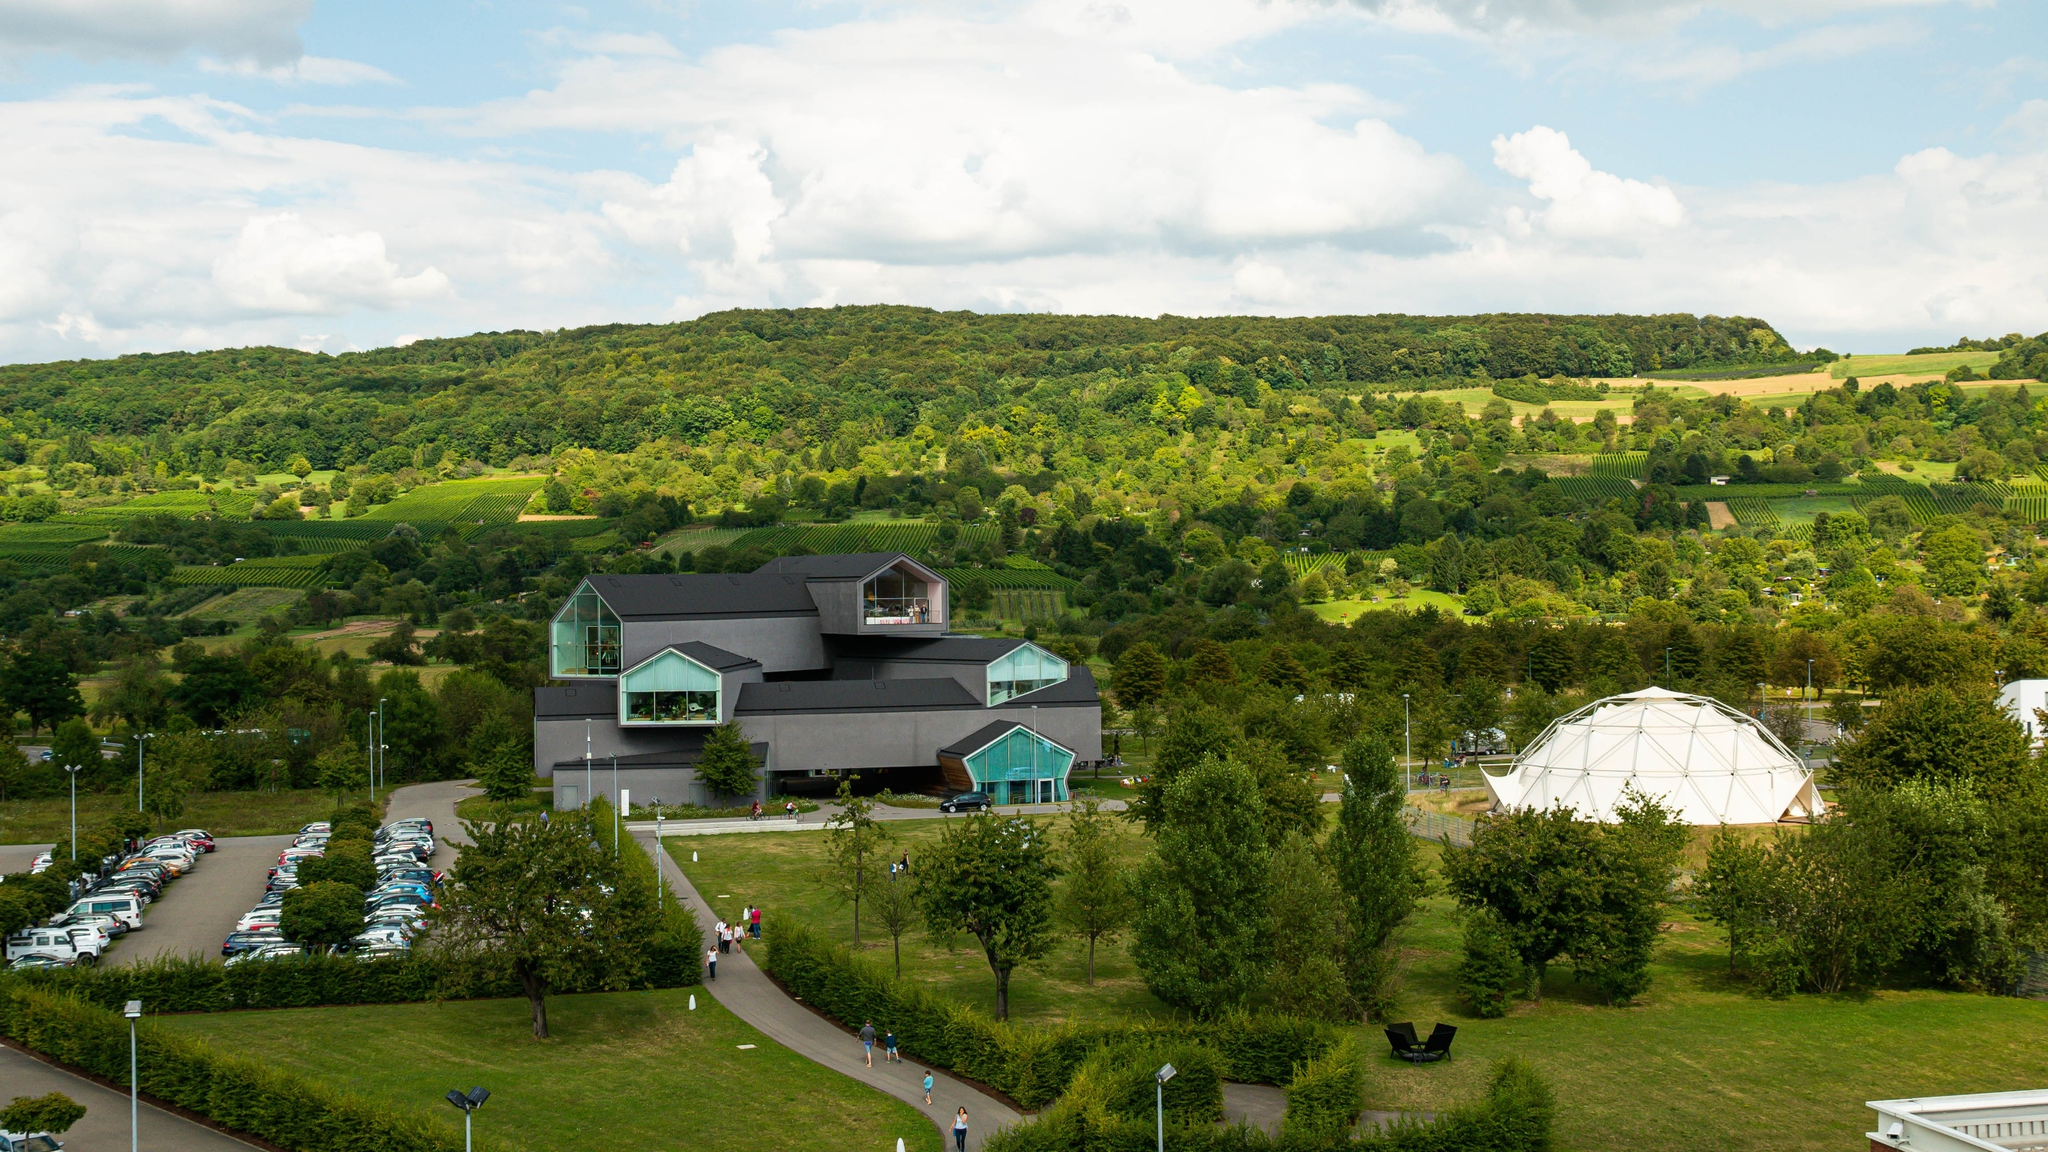Can you imagine what it would be like to visit this place on a sunny day? Visiting the Vitra Design Museum on a sunny day would be a delightful experience. The journey to the museum would likely begin with a scenic drive through the rolling hills and greenery of Weil am Rhein. Upon arrival, the sleek, black exterior of the museum would be accentuated by the bright sunlight, making the triangular windows sparkle. The numerous visitors' cars would indicate that it’s a popular destination. Walking through the museum’s surrounding gardens, one could appreciate the lush, green landscape set against the clear blue sky. The serene atmosphere, combined with the innovative architecture, would create a perfect blend of natural beauty and modern design. The nearby geodesic dome would also provide an interesting diversion, possibly housing an exhibition or another public attraction. 